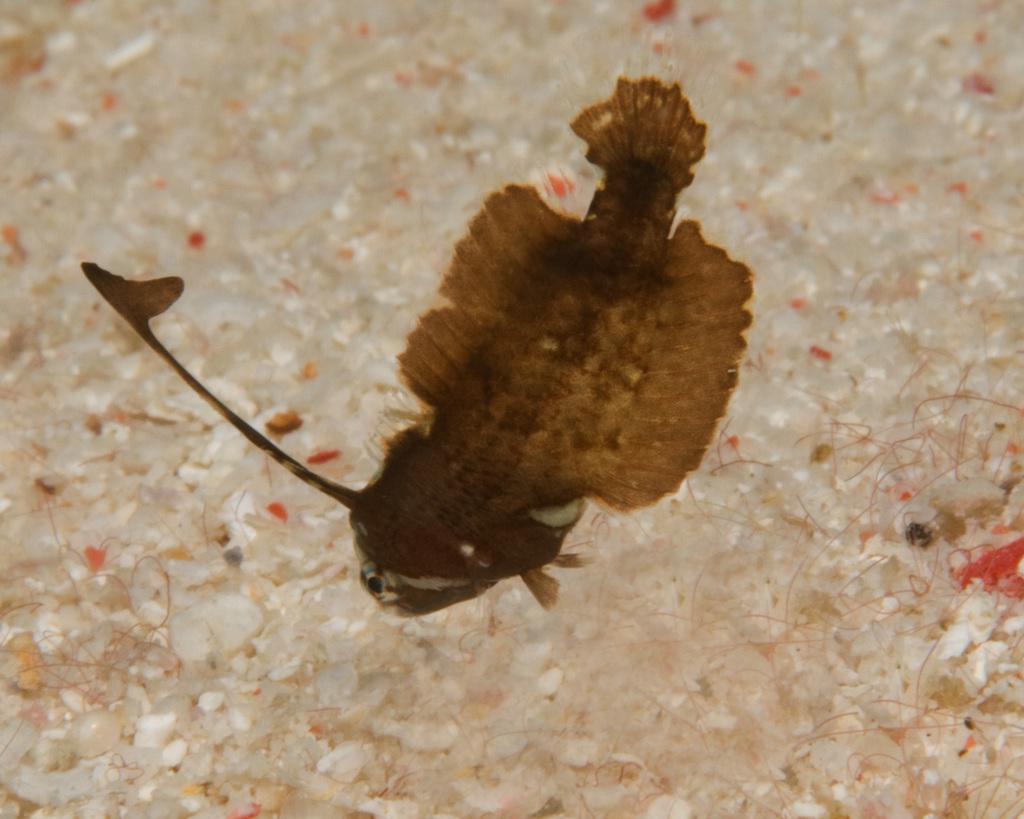Could you give a brief overview of what you see in this image? In this image we can see a fish which is of brown color. 